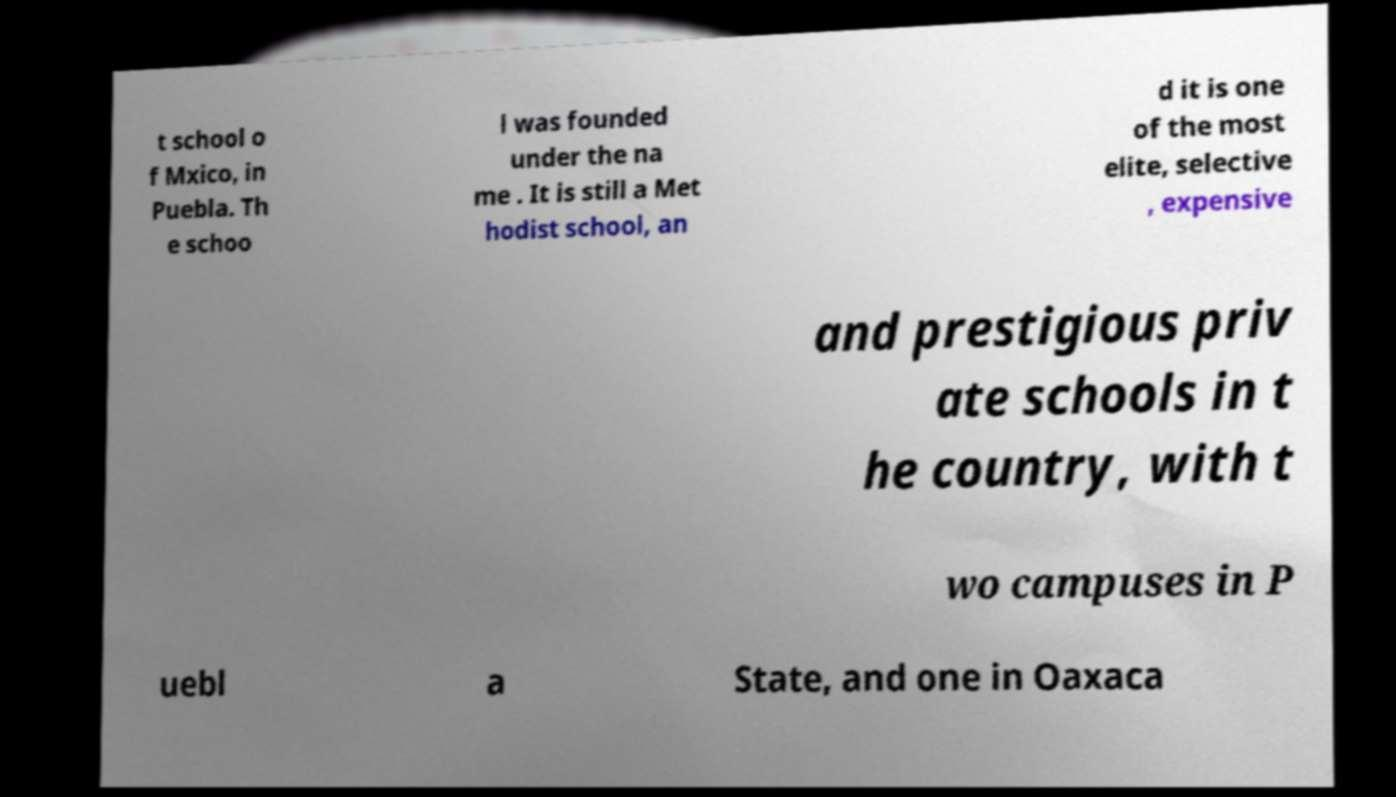Could you assist in decoding the text presented in this image and type it out clearly? t school o f Mxico, in Puebla. Th e schoo l was founded under the na me . It is still a Met hodist school, an d it is one of the most elite, selective , expensive and prestigious priv ate schools in t he country, with t wo campuses in P uebl a State, and one in Oaxaca 